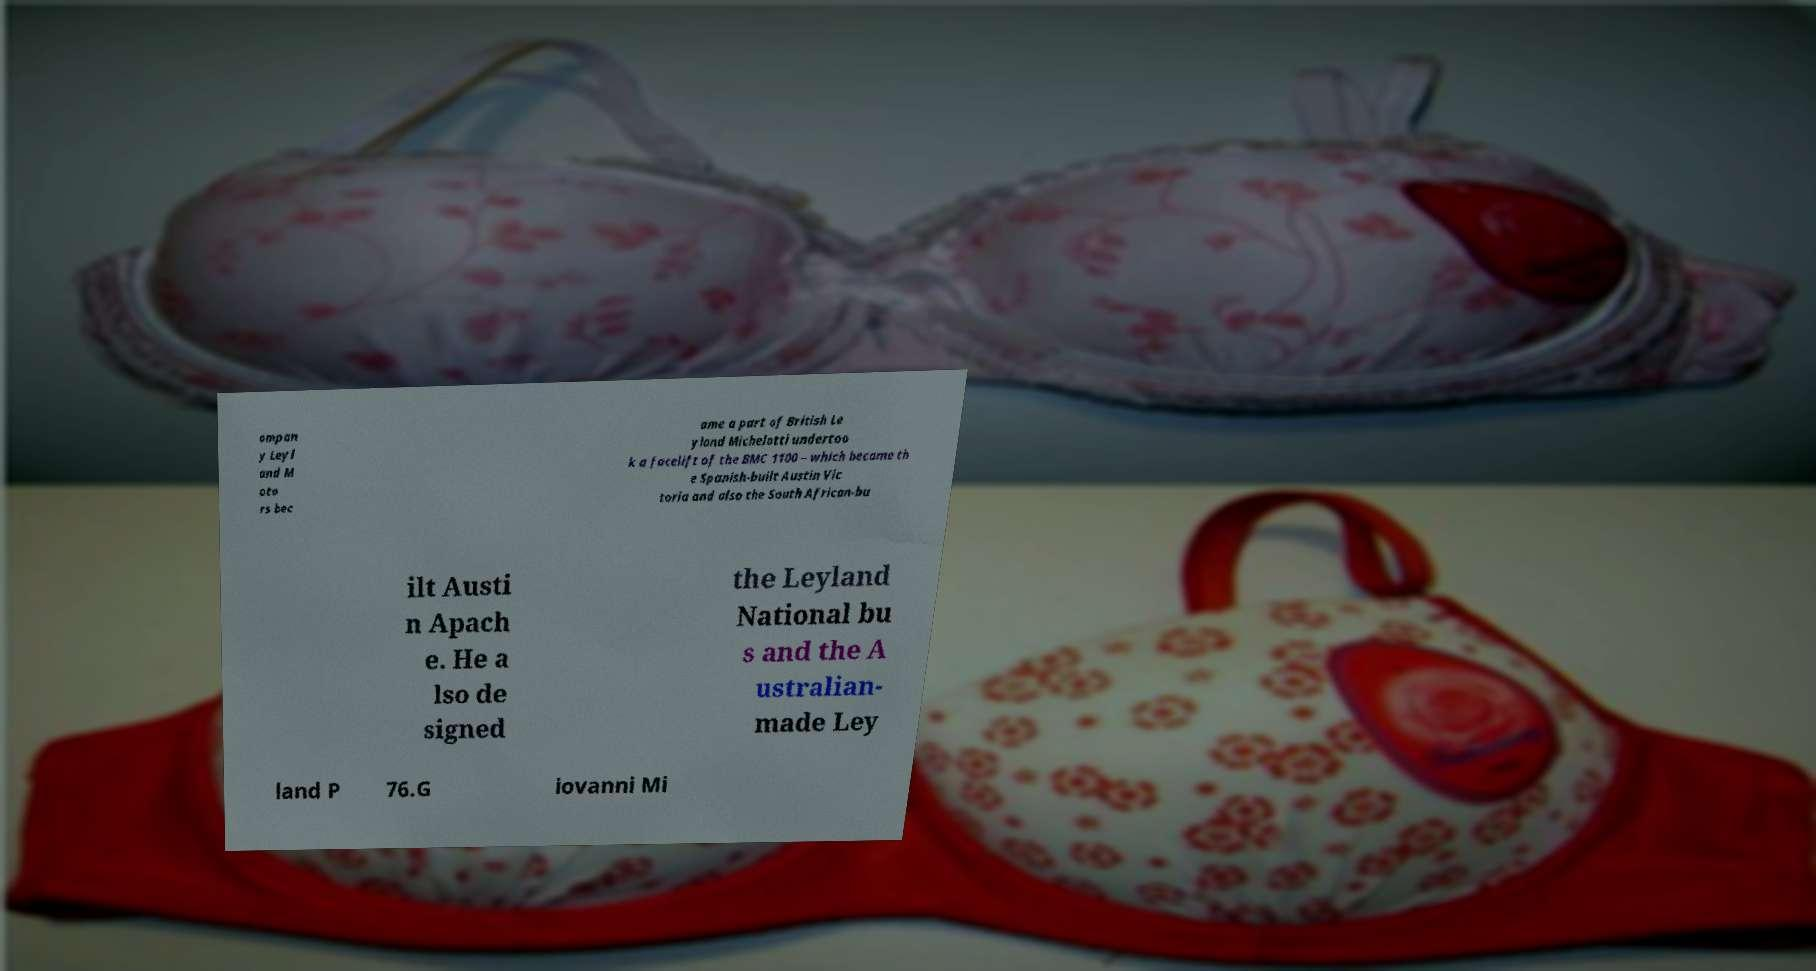There's text embedded in this image that I need extracted. Can you transcribe it verbatim? ompan y Leyl and M oto rs bec ame a part of British Le yland Michelotti undertoo k a facelift of the BMC 1100 – which became th e Spanish-built Austin Vic toria and also the South African-bu ilt Austi n Apach e. He a lso de signed the Leyland National bu s and the A ustralian- made Ley land P 76.G iovanni Mi 